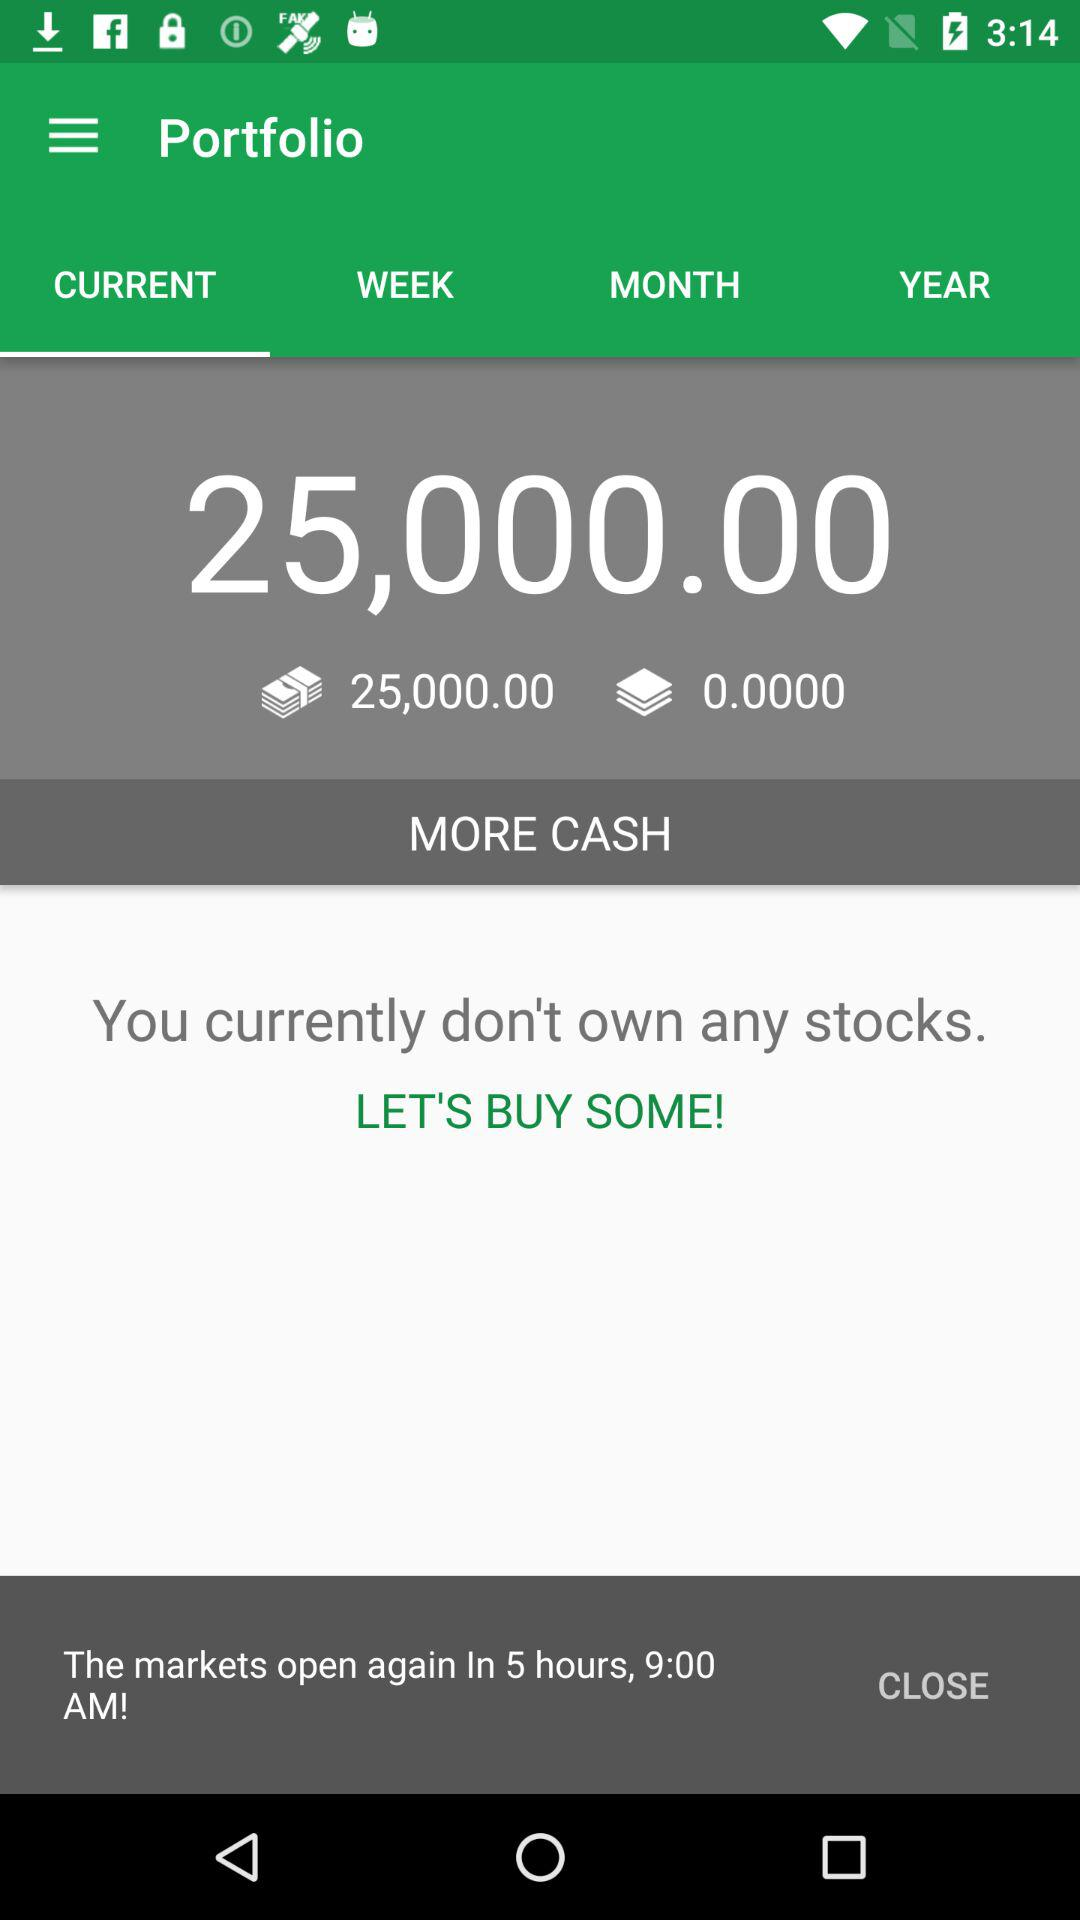How many hours until the markets open?
Answer the question using a single word or phrase. 5 